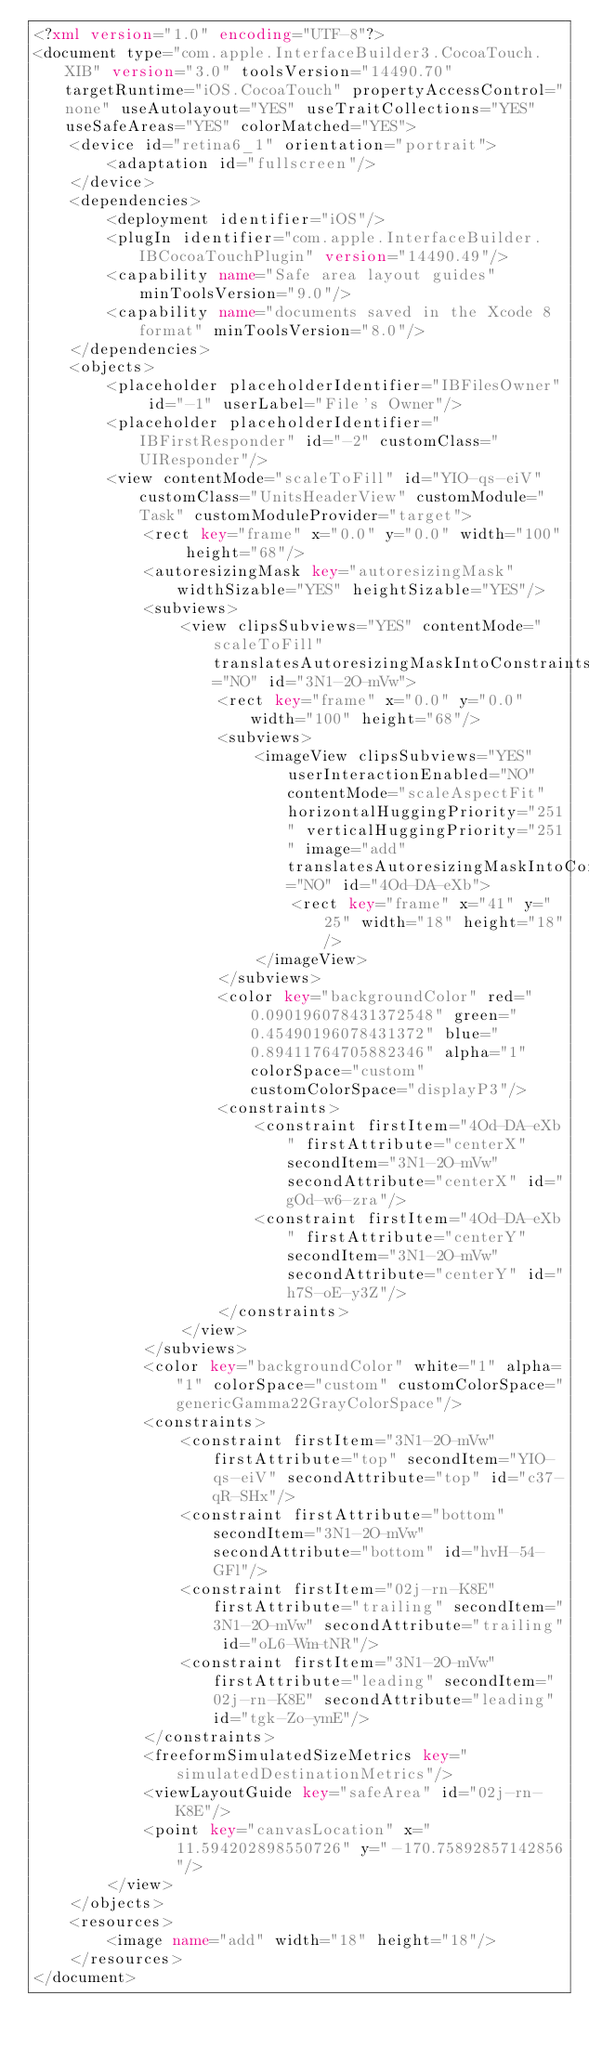<code> <loc_0><loc_0><loc_500><loc_500><_XML_><?xml version="1.0" encoding="UTF-8"?>
<document type="com.apple.InterfaceBuilder3.CocoaTouch.XIB" version="3.0" toolsVersion="14490.70" targetRuntime="iOS.CocoaTouch" propertyAccessControl="none" useAutolayout="YES" useTraitCollections="YES" useSafeAreas="YES" colorMatched="YES">
    <device id="retina6_1" orientation="portrait">
        <adaptation id="fullscreen"/>
    </device>
    <dependencies>
        <deployment identifier="iOS"/>
        <plugIn identifier="com.apple.InterfaceBuilder.IBCocoaTouchPlugin" version="14490.49"/>
        <capability name="Safe area layout guides" minToolsVersion="9.0"/>
        <capability name="documents saved in the Xcode 8 format" minToolsVersion="8.0"/>
    </dependencies>
    <objects>
        <placeholder placeholderIdentifier="IBFilesOwner" id="-1" userLabel="File's Owner"/>
        <placeholder placeholderIdentifier="IBFirstResponder" id="-2" customClass="UIResponder"/>
        <view contentMode="scaleToFill" id="YIO-qs-eiV" customClass="UnitsHeaderView" customModule="Task" customModuleProvider="target">
            <rect key="frame" x="0.0" y="0.0" width="100" height="68"/>
            <autoresizingMask key="autoresizingMask" widthSizable="YES" heightSizable="YES"/>
            <subviews>
                <view clipsSubviews="YES" contentMode="scaleToFill" translatesAutoresizingMaskIntoConstraints="NO" id="3N1-2O-mVw">
                    <rect key="frame" x="0.0" y="0.0" width="100" height="68"/>
                    <subviews>
                        <imageView clipsSubviews="YES" userInteractionEnabled="NO" contentMode="scaleAspectFit" horizontalHuggingPriority="251" verticalHuggingPriority="251" image="add" translatesAutoresizingMaskIntoConstraints="NO" id="4Od-DA-eXb">
                            <rect key="frame" x="41" y="25" width="18" height="18"/>
                        </imageView>
                    </subviews>
                    <color key="backgroundColor" red="0.090196078431372548" green="0.45490196078431372" blue="0.89411764705882346" alpha="1" colorSpace="custom" customColorSpace="displayP3"/>
                    <constraints>
                        <constraint firstItem="4Od-DA-eXb" firstAttribute="centerX" secondItem="3N1-2O-mVw" secondAttribute="centerX" id="gOd-w6-zra"/>
                        <constraint firstItem="4Od-DA-eXb" firstAttribute="centerY" secondItem="3N1-2O-mVw" secondAttribute="centerY" id="h7S-oE-y3Z"/>
                    </constraints>
                </view>
            </subviews>
            <color key="backgroundColor" white="1" alpha="1" colorSpace="custom" customColorSpace="genericGamma22GrayColorSpace"/>
            <constraints>
                <constraint firstItem="3N1-2O-mVw" firstAttribute="top" secondItem="YIO-qs-eiV" secondAttribute="top" id="c37-qR-SHx"/>
                <constraint firstAttribute="bottom" secondItem="3N1-2O-mVw" secondAttribute="bottom" id="hvH-54-GFl"/>
                <constraint firstItem="02j-rn-K8E" firstAttribute="trailing" secondItem="3N1-2O-mVw" secondAttribute="trailing" id="oL6-Wm-tNR"/>
                <constraint firstItem="3N1-2O-mVw" firstAttribute="leading" secondItem="02j-rn-K8E" secondAttribute="leading" id="tgk-Zo-ymE"/>
            </constraints>
            <freeformSimulatedSizeMetrics key="simulatedDestinationMetrics"/>
            <viewLayoutGuide key="safeArea" id="02j-rn-K8E"/>
            <point key="canvasLocation" x="11.594202898550726" y="-170.75892857142856"/>
        </view>
    </objects>
    <resources>
        <image name="add" width="18" height="18"/>
    </resources>
</document>
</code> 